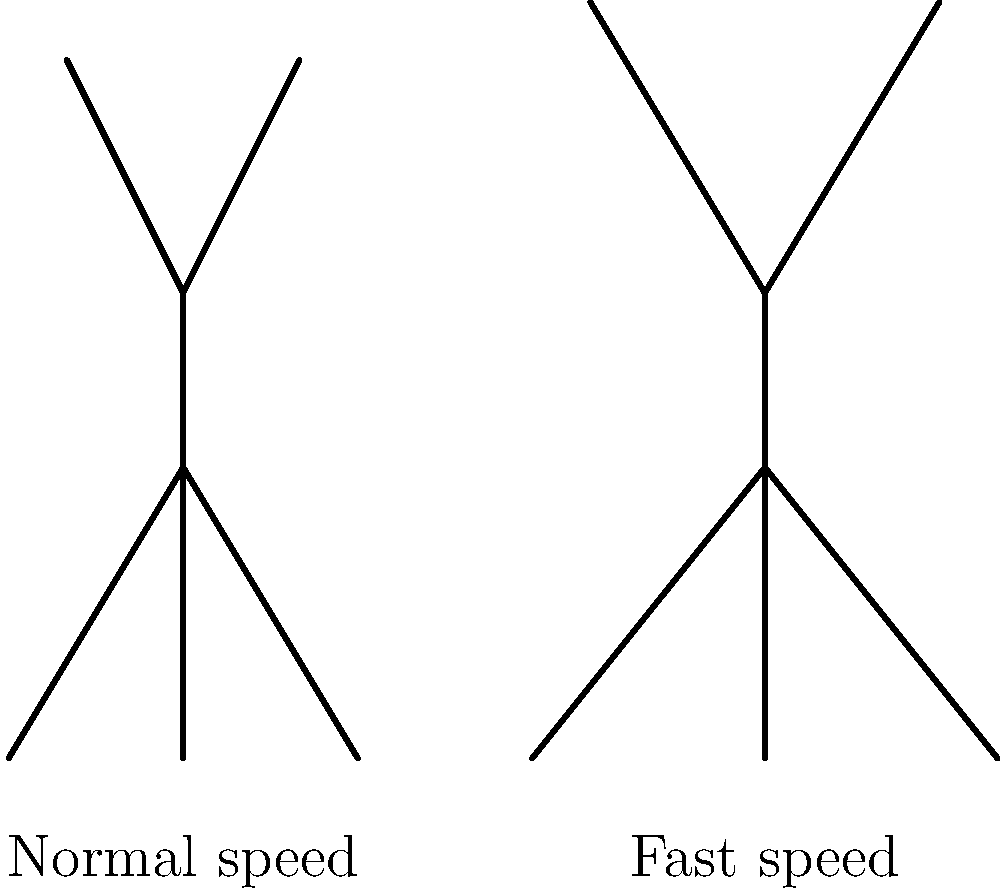Based on the stick figure diagram showing normal and fast walking speeds, how does the force distribution on joints, particularly the knee joint, change as walking speed increases? To understand the force distribution on joints during different walking speeds, let's break down the explanation:

1. Observe the stick figures: The left figure represents normal walking speed, while the right figure shows fast walking speed.

2. Notice the force arrows: The arrows at knee level indicate the force applied to the joints. The arrow for the fast-walking figure is larger, suggesting increased force.

3. Biomechanical principles:
   a) As walking speed increases, stride length typically increases.
   b) Longer strides require greater range of motion in the joints, especially the knees and hips.
   c) Faster movement means higher impact forces when the foot strikes the ground.

4. Force distribution:
   a) At normal walking speeds, forces are distributed more evenly across joints.
   b) As speed increases, the impact forces increase, particularly on weight-bearing joints like the knees.

5. Knee joint focus:
   a) During faster walking, the knee experiences higher compressive and shear forces.
   b) This is due to increased ground reaction forces and the need to absorb and propel the body more quickly.

6. Implications:
   a) Higher forces on joints, especially the knees, can lead to increased wear and tear over time.
   b) This is why proper footwear and gradual increases in exercise intensity are important for joint health.

In summary, as walking speed increases, the force distribution on joints, particularly the knee joint, becomes greater and more concentrated, potentially leading to increased stress on these structures.
Answer: Force on knee joints increases with walking speed 